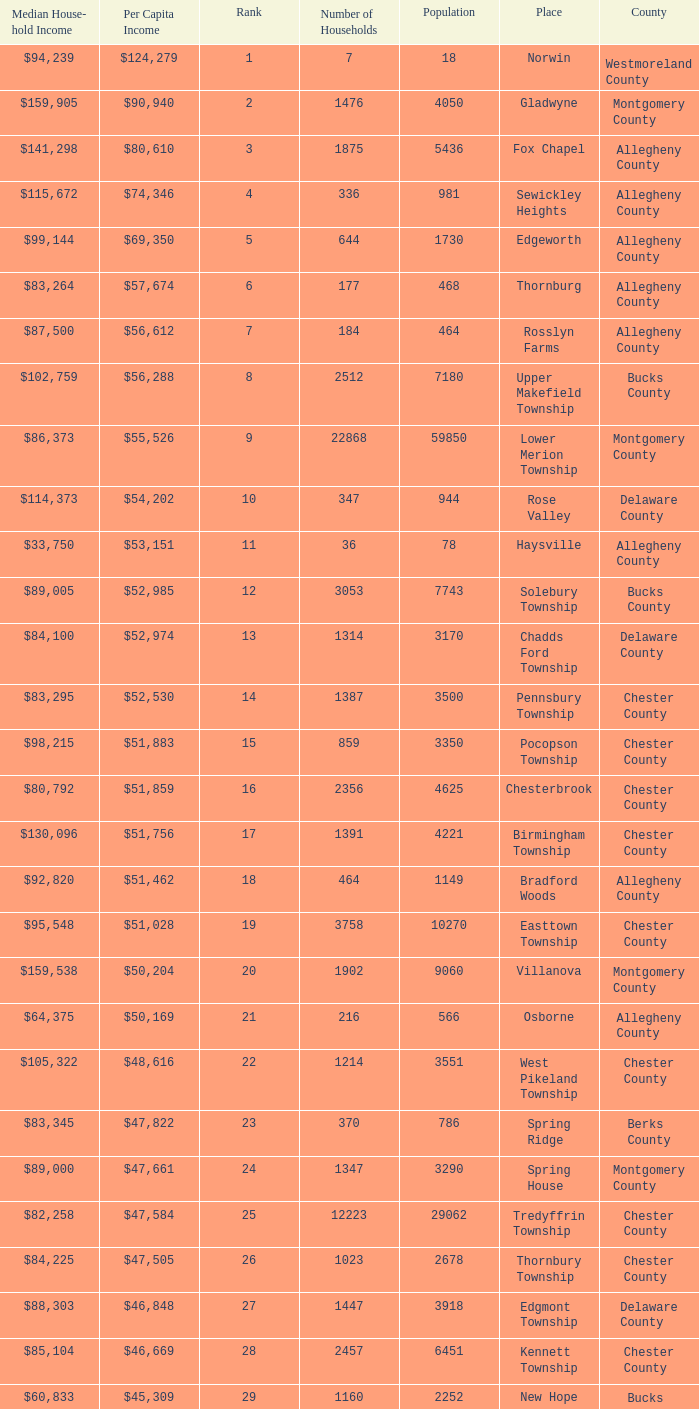What county has 2053 households?  Chester County. 